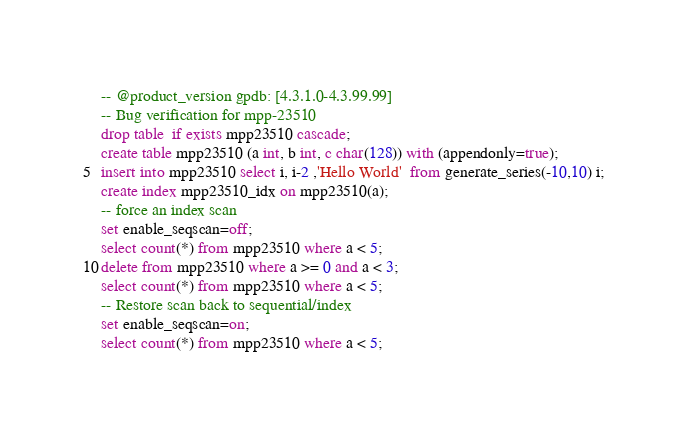<code> <loc_0><loc_0><loc_500><loc_500><_SQL_>-- @product_version gpdb: [4.3.1.0-4.3.99.99]
-- Bug verification for mpp-23510
drop table  if exists mpp23510 cascade;
create table mpp23510 (a int, b int, c char(128)) with (appendonly=true);
insert into mpp23510 select i, i-2 ,'Hello World'  from generate_series(-10,10) i;
create index mpp23510_idx on mpp23510(a);
-- force an index scan
set enable_seqscan=off;
select count(*) from mpp23510 where a < 5;
delete from mpp23510 where a >= 0 and a < 3;
select count(*) from mpp23510 where a < 5;
-- Restore scan back to sequential/index
set enable_seqscan=on;
select count(*) from mpp23510 where a < 5;</code> 